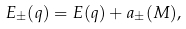Convert formula to latex. <formula><loc_0><loc_0><loc_500><loc_500>E _ { \pm } ( q ) = E ( q ) + a _ { \pm } ( M ) ,</formula> 